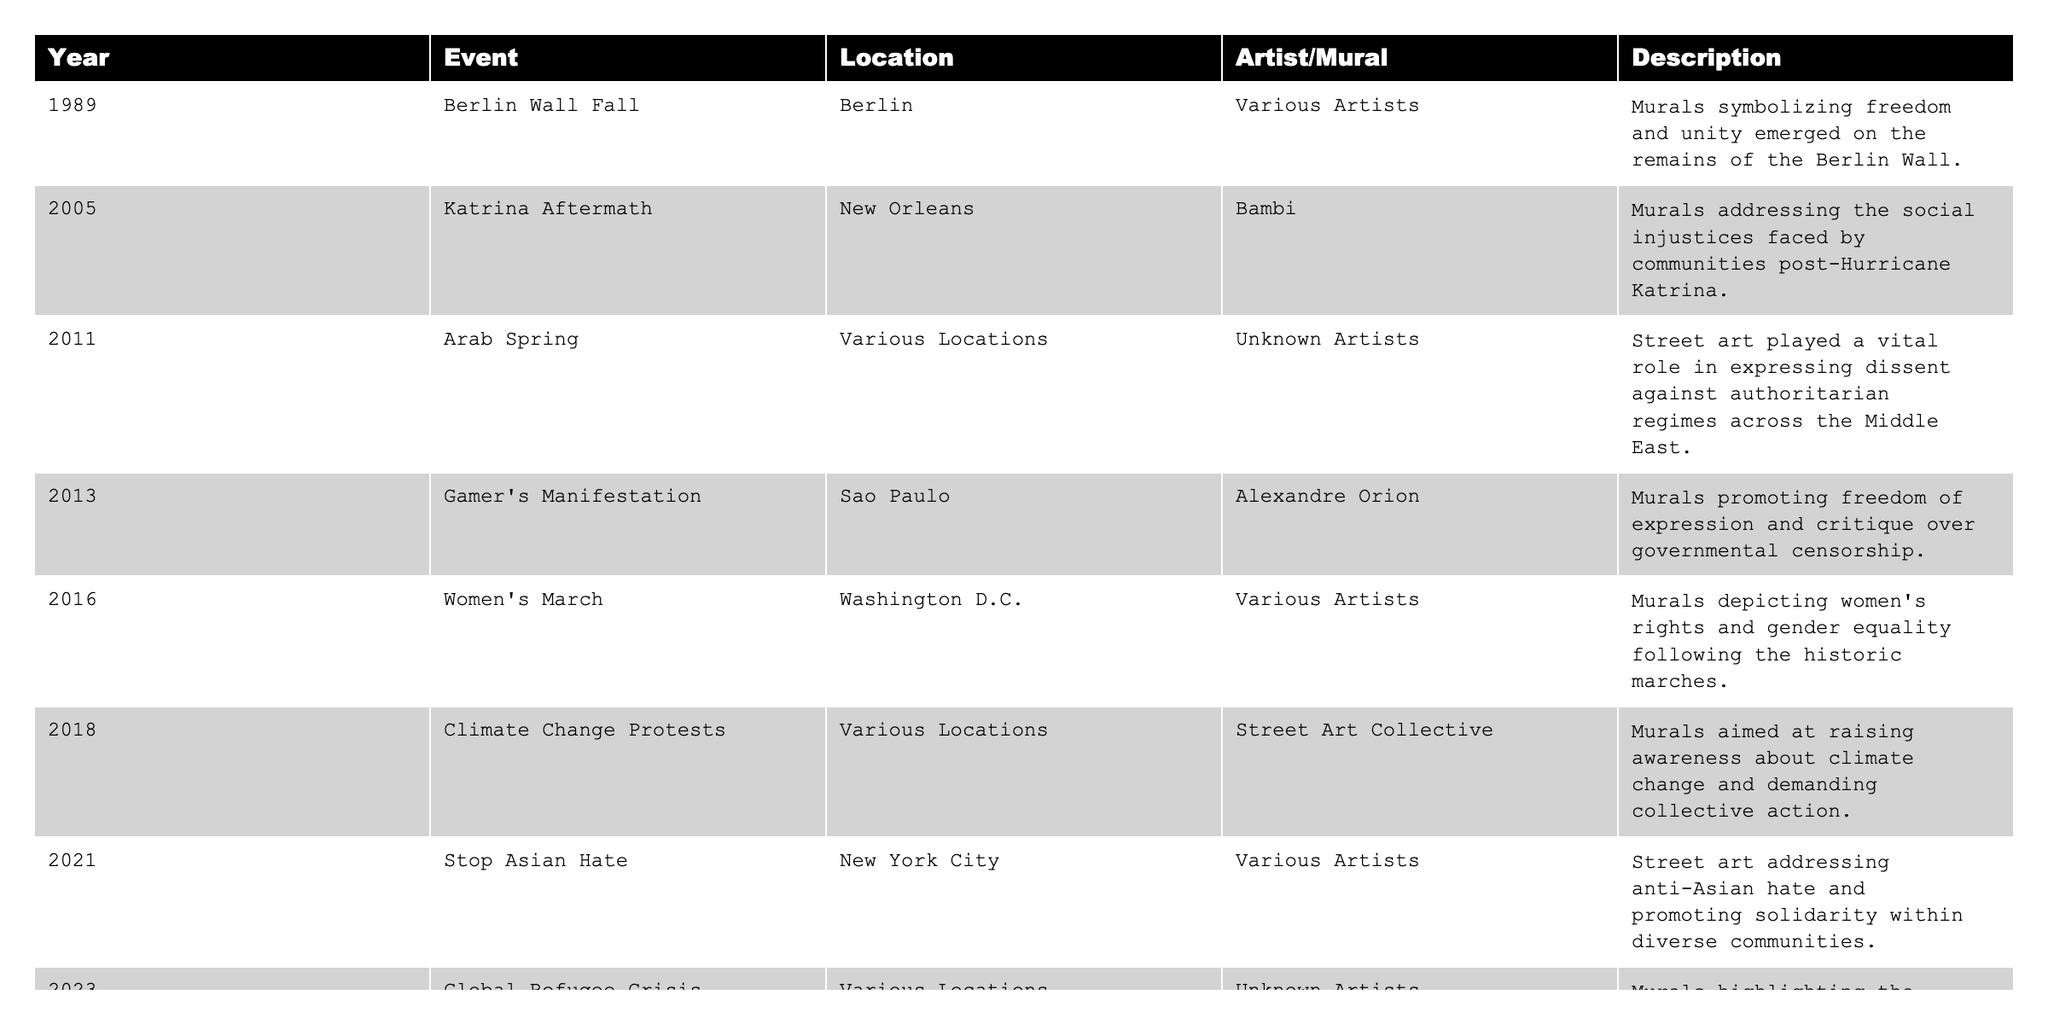What year did the Women's March occur? The Women's March is listed in the table under the Year column. It is stated to have occurred in 2016.
Answer: 2016 Which event was associated with murals addressing social injustices faced by communities? The event associated with addressing social injustices is the "Katrina Aftermath," which took place in New Orleans in 2005, as indicated in the Description column.
Answer: Katrina Aftermath How many events took place in 2021? According to the table, there is one event listed for the year 2021, which is "Stop Asian Hate" in New York City.
Answer: 1 Which event focused on raising awareness about climate change? The "Climate Change Protests" event, listed in 2018, is specifically mentioned for raising awareness about climate change in the Description column.
Answer: Climate Change Protests True or False: The "Arab Spring" murals were created by known artists. According to the table, the Arab Spring murals are categorized under "Unknown Artists," indicating that this statement is false.
Answer: False What is the total number of events documented in the table? By counting the number of entries in the table, we find that there are eight events listed overall.
Answer: 8 In which city did the "Global Refugee Crisis" mural event occur? The "Global Refugee Crisis" event took place in various locations, as noted in the Location column; it is not confined to a single city.
Answer: Various Locations What is the sequence of events from the Berlin Wall Fall to the Stop Asian Hate? Looking at the table, the timeline of these two events shows: "Berlin Wall Fall" in 1989, followed by "Katrina Aftermath" in 2005, "Arab Spring" in 2011, "Gamer's Manifestation" in 2013, "Women's March" in 2016, and finally "Stop Asian Hate" in 2021, indicating a progression of political movements captured in murals from 1989 to 2021.
Answer: Berlin Wall Fall, Katrina Aftermath, Arab Spring, Gamer's Manifestation, Women's March, Stop Asian Hate How many events occurred between 2011 and 2018? Events listed between those years are "Arab Spring" (2011), "Gamer's Manifestation" (2013), "Women's March" (2016), and "Climate Change Protests" (2018). Counting these, there are four events.
Answer: 4 Identify the location of the "Katrina Aftermath" murals. The table specifies that the "Katrina Aftermath" murals were located in New Orleans, as stated in the Location column.
Answer: New Orleans 